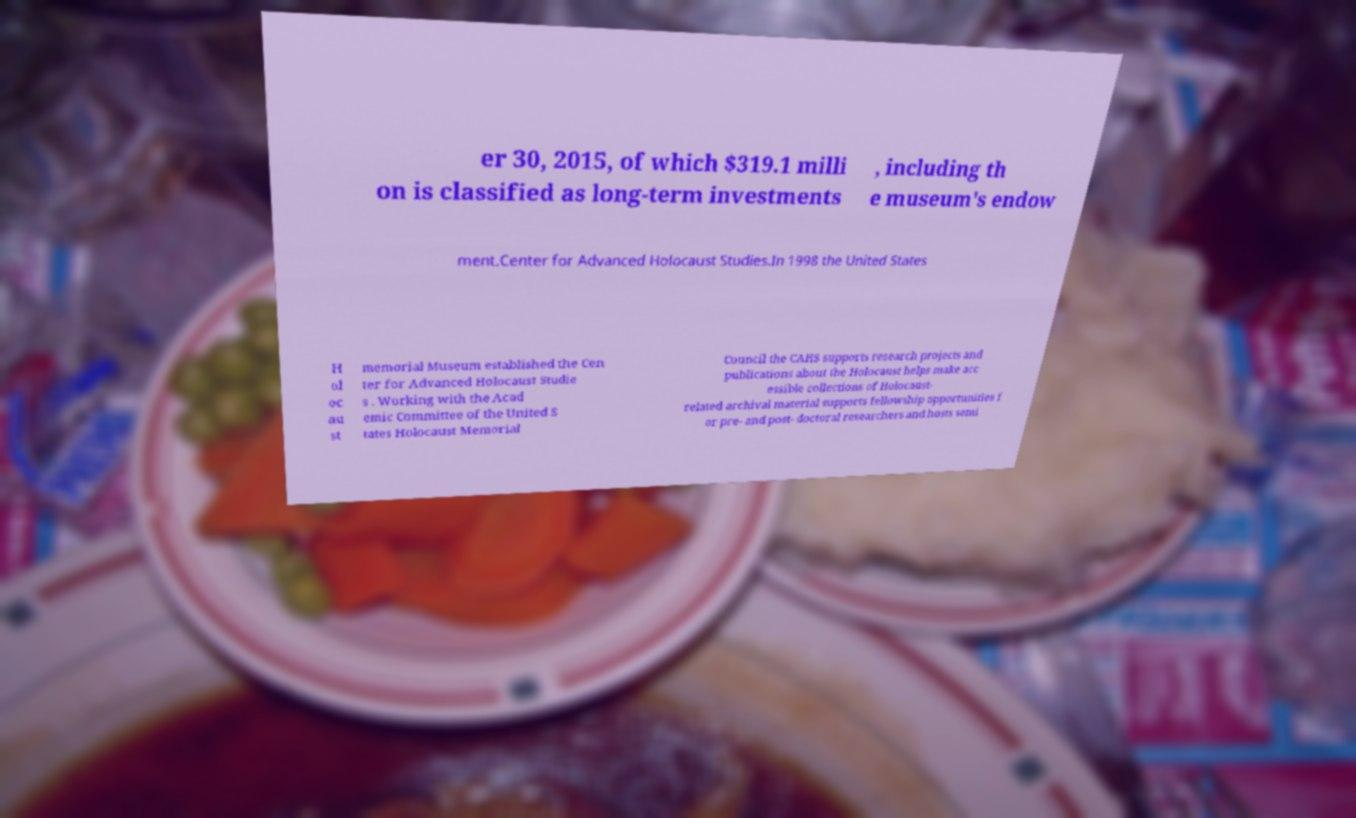Please identify and transcribe the text found in this image. er 30, 2015, of which $319.1 milli on is classified as long-term investments , including th e museum's endow ment.Center for Advanced Holocaust Studies.In 1998 the United States H ol oc au st memorial Museum established the Cen ter for Advanced Holocaust Studie s . Working with the Acad emic Committee of the United S tates Holocaust Memorial Council the CAHS supports research projects and publications about the Holocaust helps make acc essible collections of Holocaust- related archival material supports fellowship opportunities f or pre- and post- doctoral researchers and hosts semi 